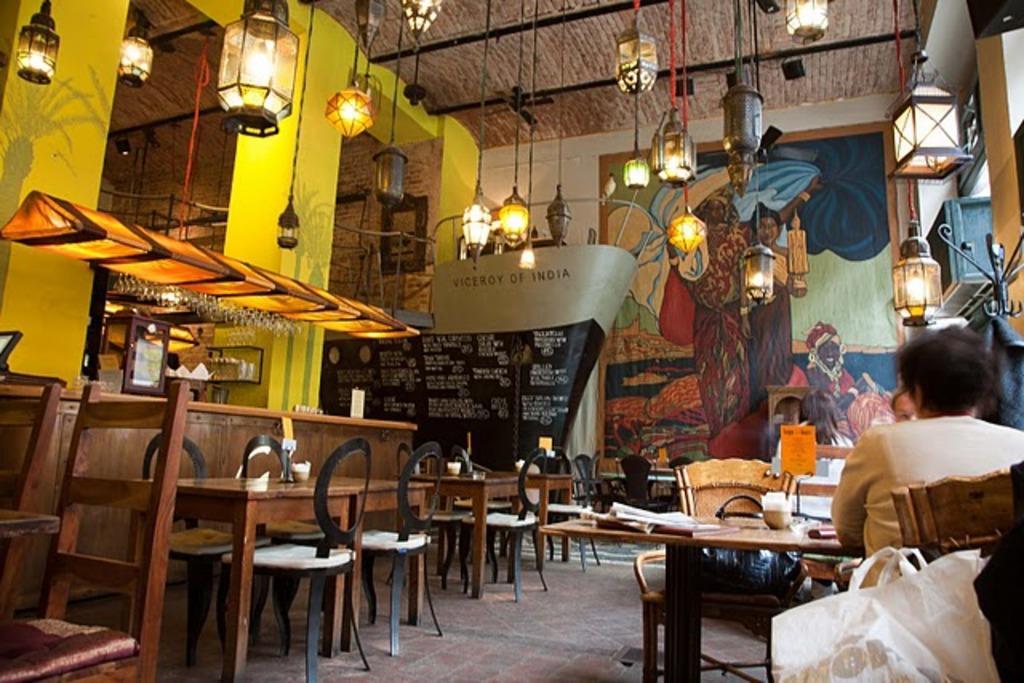Could you give a brief overview of what you see in this image? In this picture a person is seated on the chair, in front of the person we can find a glass and papers on the table, and also we can find couple of tables, chairs in this room, in front of them we can see a wall painting and couple of lights. 